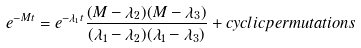Convert formula to latex. <formula><loc_0><loc_0><loc_500><loc_500>e ^ { - M t } = e ^ { - \lambda _ { 1 } t } \frac { ( M - \lambda _ { 2 } ) ( M - \lambda _ { 3 } ) } { ( \lambda _ { 1 } - \lambda _ { 2 } ) ( \lambda _ { 1 } - \lambda _ { 3 } ) } + c y c l i c p e r m u t a t i o n s</formula> 